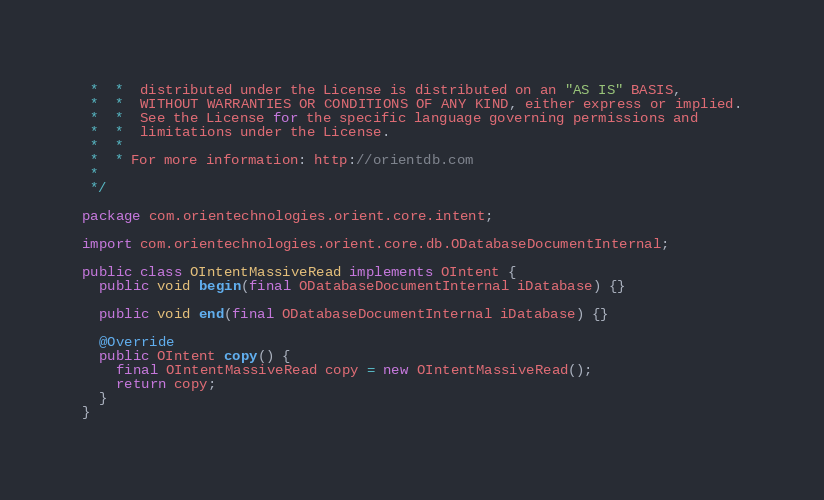Convert code to text. <code><loc_0><loc_0><loc_500><loc_500><_Java_> *  *  distributed under the License is distributed on an "AS IS" BASIS,
 *  *  WITHOUT WARRANTIES OR CONDITIONS OF ANY KIND, either express or implied.
 *  *  See the License for the specific language governing permissions and
 *  *  limitations under the License.
 *  *
 *  * For more information: http://orientdb.com
 *
 */

package com.orientechnologies.orient.core.intent;

import com.orientechnologies.orient.core.db.ODatabaseDocumentInternal;

public class OIntentMassiveRead implements OIntent {
  public void begin(final ODatabaseDocumentInternal iDatabase) {}

  public void end(final ODatabaseDocumentInternal iDatabase) {}

  @Override
  public OIntent copy() {
    final OIntentMassiveRead copy = new OIntentMassiveRead();
    return copy;
  }
}
</code> 